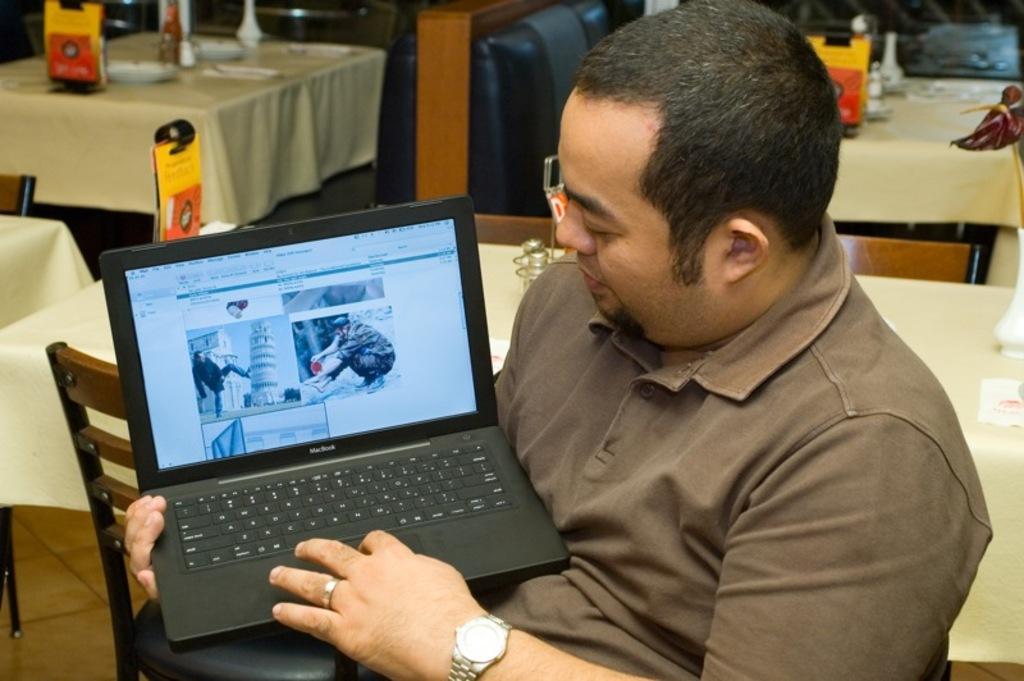Can you describe this image briefly? Here in this picture we can see a person sitting on a chair and he i s holding a laptop in his hands and behind him we can see chairs and tables present all over there and we can see glasses and some plates present on the table here and there. 